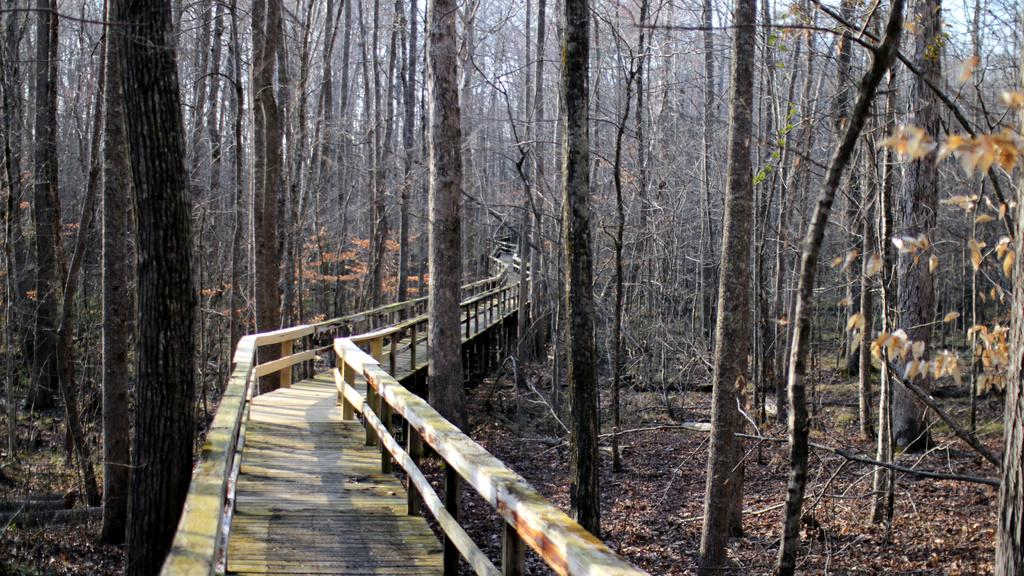What type of walkway is present in the image? There is a wooden walkway in the image. Where is the wooden walkway located? The walkway is located in a forest. What can be observed about the trees surrounding the walkway? The trees surrounding the walkway appear to be dry. What type of prose can be heard being recited by the tiger in the image? There is no tiger present in the image, and therefore no prose can be heard being recited. 